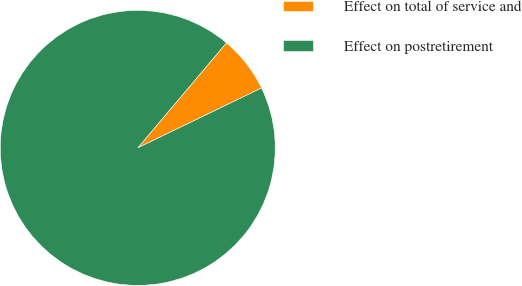Convert chart to OTSL. <chart><loc_0><loc_0><loc_500><loc_500><pie_chart><fcel>Effect on total of service and<fcel>Effect on postretirement<nl><fcel>6.67%<fcel>93.33%<nl></chart> 